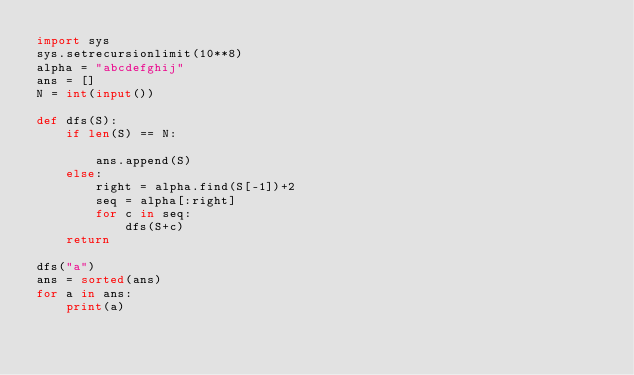Convert code to text. <code><loc_0><loc_0><loc_500><loc_500><_Python_>import sys
sys.setrecursionlimit(10**8)
alpha = "abcdefghij"
ans = []
N = int(input())

def dfs(S):
    if len(S) == N:

        ans.append(S)
    else:
        right = alpha.find(S[-1])+2
        seq = alpha[:right]
        for c in seq:
            dfs(S+c)
    return

dfs("a")
ans = sorted(ans)
for a in ans:
    print(a)</code> 